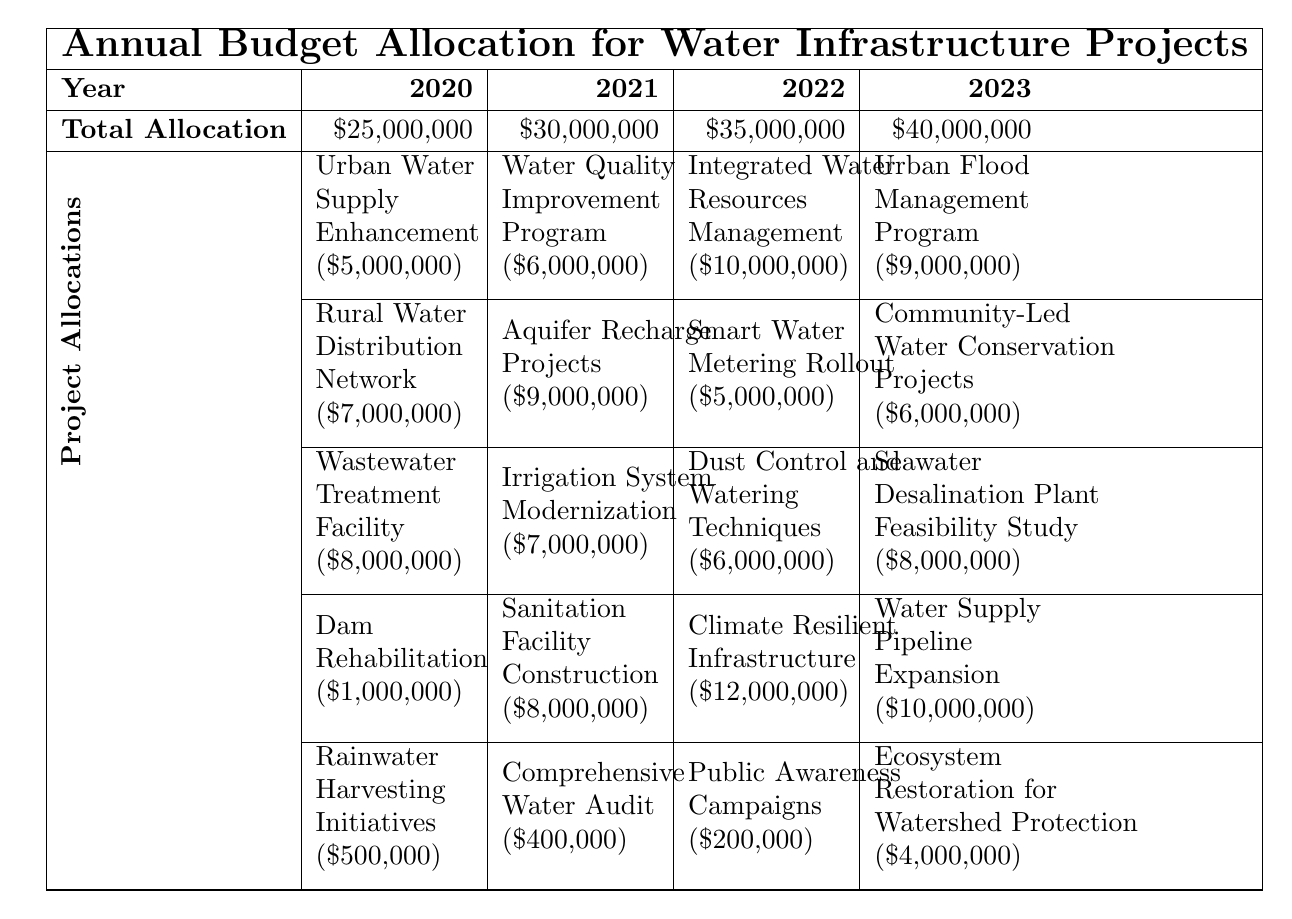What was the total allocation for the year 2021? The total allocation for the year 2021 is indicated in the table and corresponds to the row for "Total Allocation" under the column for 2021. It shows a value of $30,000,000.
Answer: $30,000,000 Which project received the highest allocation in 2022? The project with the highest allocation in 2022 is listed under the "Project Allocations" for that year. It shows "Climate Resilient Infrastructure" with an allocation of $12,000,000.
Answer: Climate Resilient Infrastructure What is the total allocation for water infrastructure projects from 2020 to 2023? To find the total allocation, we sum the total allocations for each year: $25,000,000 (2020) + $30,000,000 (2021) + $35,000,000 (2022) + $40,000,000 (2023) = $130,000,000.
Answer: $130,000,000 What was the increase in total allocation from 2020 to 2023? The increase can be calculated by subtracting the total allocation for 2020 from that of 2023: $40,000,000 (2023) - $25,000,000 (2020) = $15,000,000.
Answer: $15,000,000 Is there a project focused on rainwater harvesting in 2020? Referring to the 2020 section, the "Rainwater Harvesting Initiatives" project is listed, indicating that there is indeed a project focused on this area.
Answer: Yes How much was allocated to sanitation facilities construction relative to the total allocation in 2021? In 2021, "Sanitation Facility Construction" received $8,000,000. To find the relative allocation, we compute ($8,000,000 / $30,000,000) * 100, which gives approximately 26.67%.
Answer: 26.67% What is the total funding for infrastructure projects aimed at enhancing water supply from 2020 to 2023? Summing the specific allocations for water supply-related projects: $5,000,000 (2020 Urban Water Supply) + $10,000,000 (2022 Water Supply Pipeline Expansion) + $9,000,000 (2023 Urban Flood Management) = $24,000,000.
Answer: $24,000,000 Which year saw the largest single project allocation and what was it? By examining each year's project allocations, the largest single project allocation is $12,000,000 in 2022 for "Climate Resilient Infrastructure."
Answer: 2022, $12,000,000 What is the average allocation per project for the year 2022? Count the number of projects in 2022 (5), then sum their allocations: $10,000,000 + $5,000,000 + $6,000,000 + $12,000,000 + $200,000 = $33,200,000. Therefore, the average is $33,200,000 / 5 = $6,640,000.
Answer: $6,640,000 Was there an allocation for a project related to ecosystem restoration in 2023? Yes, the table shows "Ecosystem Restoration for Watershed Protection" listed under 2023 with an allocation of $4,000,000, confirming the presence of this project.
Answer: Yes 